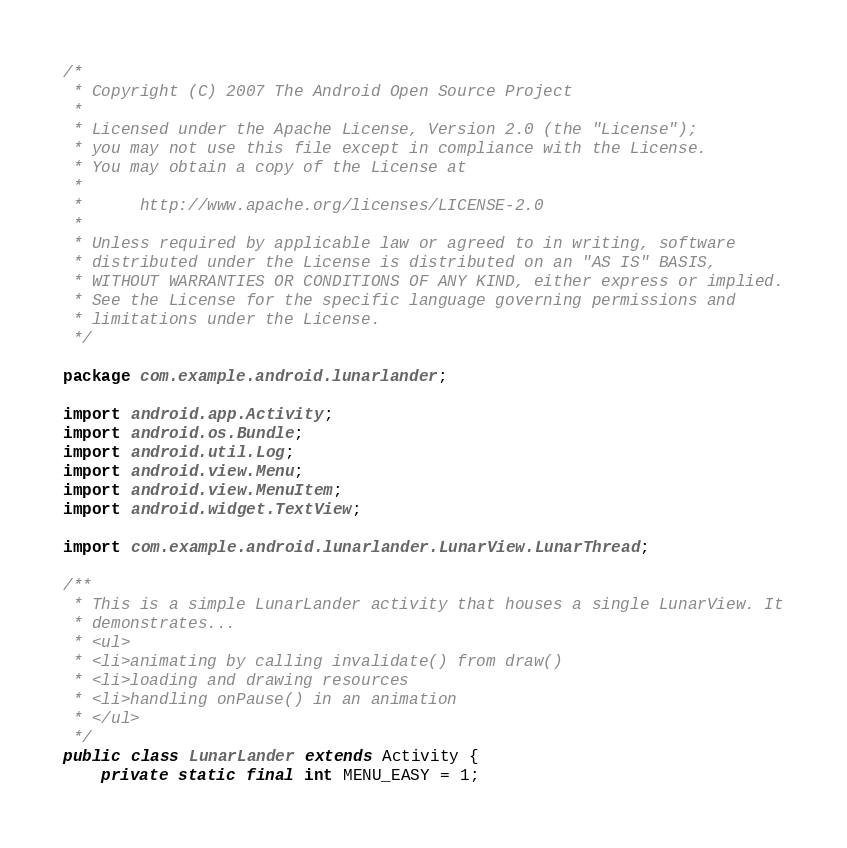<code> <loc_0><loc_0><loc_500><loc_500><_Java_>/*
 * Copyright (C) 2007 The Android Open Source Project
 *
 * Licensed under the Apache License, Version 2.0 (the "License");
 * you may not use this file except in compliance with the License.
 * You may obtain a copy of the License at
 *
 *      http://www.apache.org/licenses/LICENSE-2.0
 *
 * Unless required by applicable law or agreed to in writing, software
 * distributed under the License is distributed on an "AS IS" BASIS,
 * WITHOUT WARRANTIES OR CONDITIONS OF ANY KIND, either express or implied.
 * See the License for the specific language governing permissions and
 * limitations under the License.
 */

package com.example.android.lunarlander;

import android.app.Activity;
import android.os.Bundle;
import android.util.Log;
import android.view.Menu;
import android.view.MenuItem;
import android.widget.TextView;

import com.example.android.lunarlander.LunarView.LunarThread;

/**
 * This is a simple LunarLander activity that houses a single LunarView. It
 * demonstrates...
 * <ul>
 * <li>animating by calling invalidate() from draw()
 * <li>loading and drawing resources
 * <li>handling onPause() in an animation
 * </ul>
 */
public class LunarLander extends Activity {
    private static final int MENU_EASY = 1;
</code> 